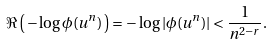Convert formula to latex. <formula><loc_0><loc_0><loc_500><loc_500>\Re \left ( \, - \log \phi ( u ^ { n } ) \, \right ) = - \log | \phi ( u ^ { n } ) | < \frac { 1 } { n ^ { 2 - r } } .</formula> 